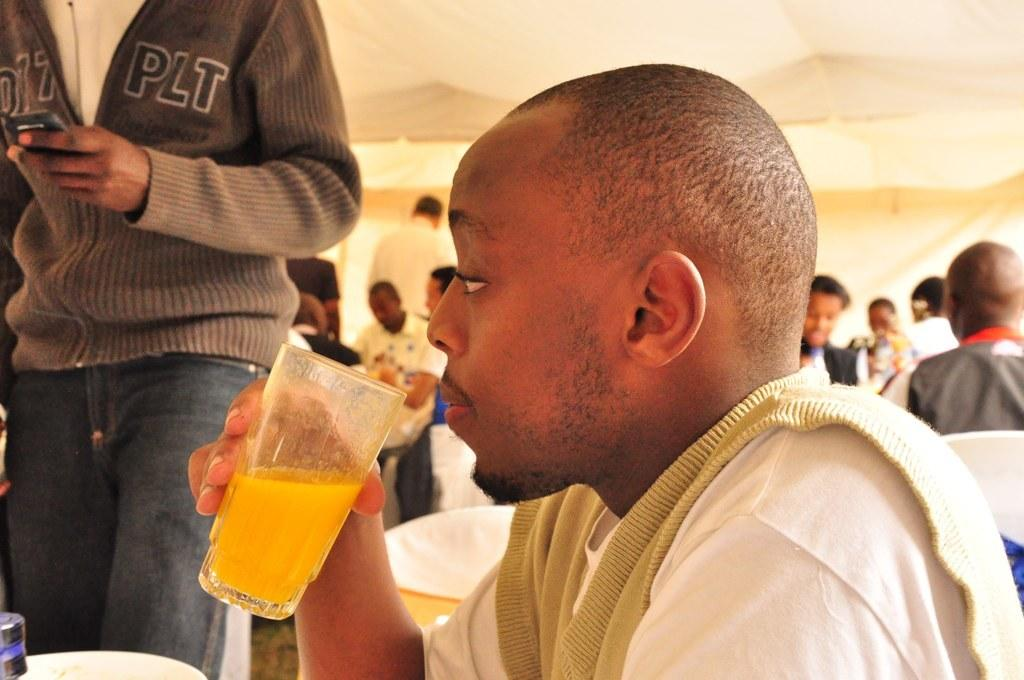What are the people in the image doing? There are people sitting on chairs and some people standing on the floor in the image. Can you describe the actions of the person holding an object in their hand? One person is holding a beverage tumbler in their hand. What type of hate can be seen on the person's face in the image? There is no hate visible on anyone's face in the image. Can you describe the hand gestures of the people in the image? The provided facts do not mention any hand gestures, so we cannot describe them. 